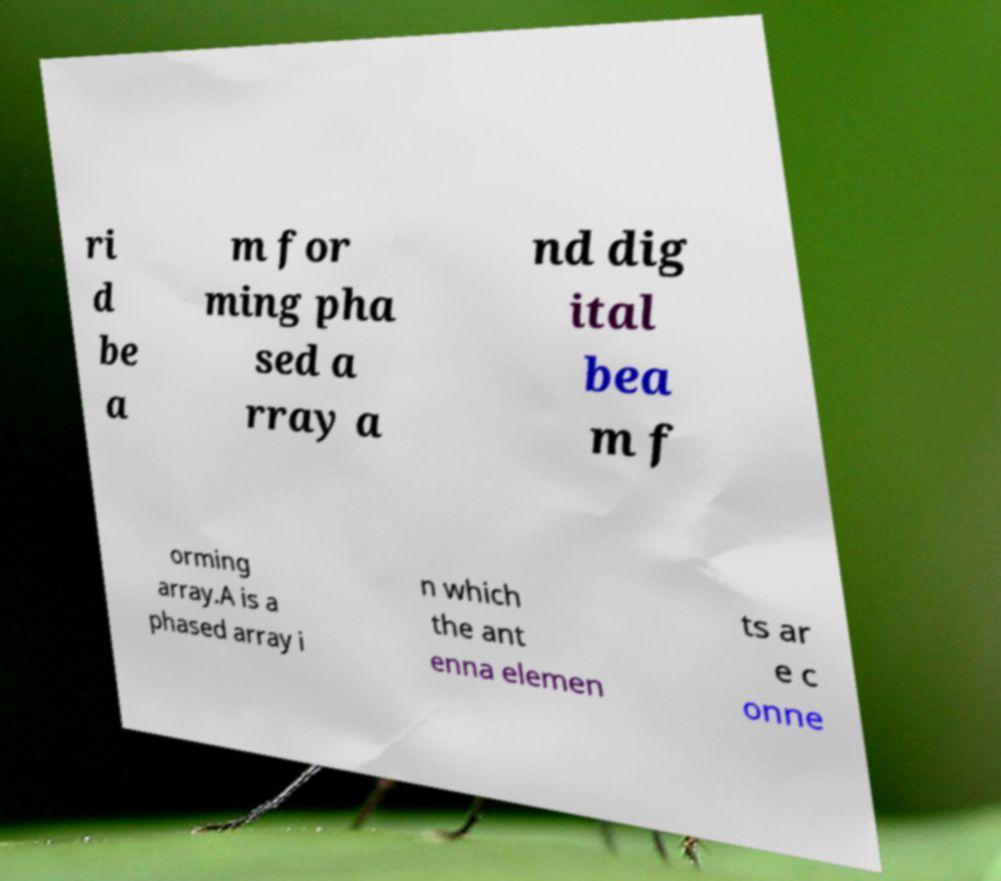For documentation purposes, I need the text within this image transcribed. Could you provide that? ri d be a m for ming pha sed a rray a nd dig ital bea m f orming array.A is a phased array i n which the ant enna elemen ts ar e c onne 